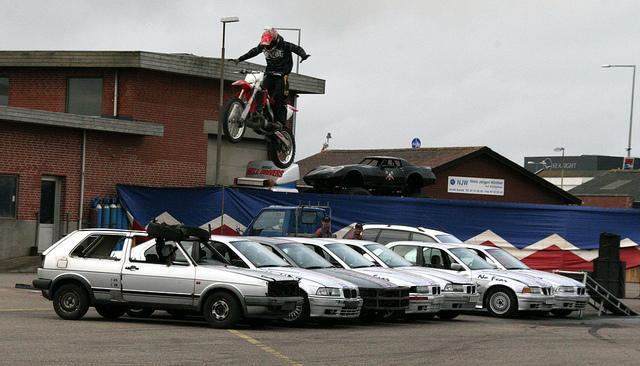How many cars are there?
Give a very brief answer. 7. How many cars can you see?
Give a very brief answer. 7. 